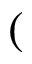Convert formula to latex. <formula><loc_0><loc_0><loc_500><loc_500>(</formula> 